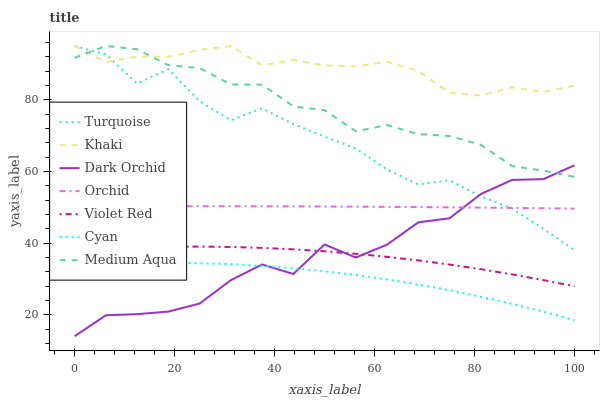Does Cyan have the minimum area under the curve?
Answer yes or no. Yes. Does Khaki have the maximum area under the curve?
Answer yes or no. Yes. Does Violet Red have the minimum area under the curve?
Answer yes or no. No. Does Violet Red have the maximum area under the curve?
Answer yes or no. No. Is Orchid the smoothest?
Answer yes or no. Yes. Is Dark Orchid the roughest?
Answer yes or no. Yes. Is Khaki the smoothest?
Answer yes or no. No. Is Khaki the roughest?
Answer yes or no. No. Does Violet Red have the lowest value?
Answer yes or no. No. Does Medium Aqua have the highest value?
Answer yes or no. Yes. Does Violet Red have the highest value?
Answer yes or no. No. Is Violet Red less than Khaki?
Answer yes or no. Yes. Is Medium Aqua greater than Violet Red?
Answer yes or no. Yes. Does Turquoise intersect Khaki?
Answer yes or no. Yes. Is Turquoise less than Khaki?
Answer yes or no. No. Is Turquoise greater than Khaki?
Answer yes or no. No. Does Violet Red intersect Khaki?
Answer yes or no. No. 